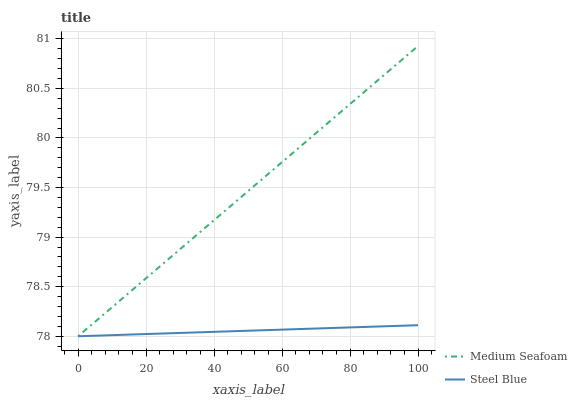Does Steel Blue have the maximum area under the curve?
Answer yes or no. No. Is Steel Blue the smoothest?
Answer yes or no. No. Does Steel Blue have the highest value?
Answer yes or no. No. 